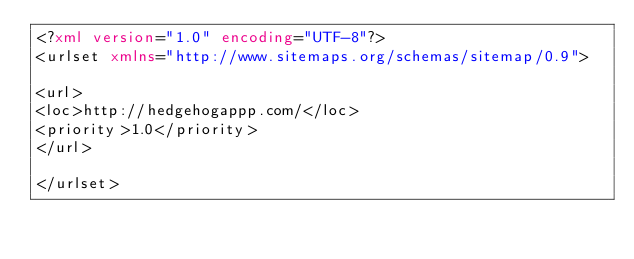Convert code to text. <code><loc_0><loc_0><loc_500><loc_500><_XML_><?xml version="1.0" encoding="UTF-8"?>
<urlset xmlns="http://www.sitemaps.org/schemas/sitemap/0.9">
 
<url>
<loc>http://hedgehogappp.com/</loc>
<priority>1.0</priority>
</url>
 
</urlset>
</code> 